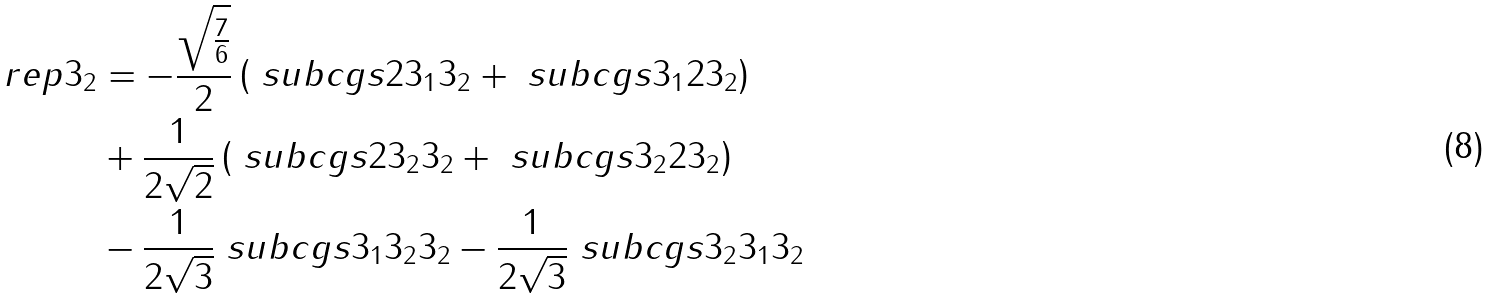Convert formula to latex. <formula><loc_0><loc_0><loc_500><loc_500>\ r e p { 3 } _ { 2 } & = - \frac { \sqrt { \frac { 7 } { 6 } } } { 2 } \left ( \ s u b c g s { 2 } { 3 _ { 1 } } { 3 _ { 2 } } + \ s u b c g s { 3 _ { 1 } } { 2 } { 3 _ { 2 } } \right ) \\ & + \frac { 1 } { 2 \sqrt { 2 } } \left ( \ s u b c g s { 2 } { 3 _ { 2 } } { 3 _ { 2 } } + \ s u b c g s { 3 _ { 2 } } { 2 } { 3 _ { 2 } } \right ) \\ & - \frac { 1 } { 2 \sqrt { 3 } } \ s u b c g s { 3 _ { 1 } } { 3 _ { 2 } } { 3 _ { 2 } } - \frac { 1 } { 2 \sqrt { 3 } } \ s u b c g s { 3 _ { 2 } } { 3 _ { 1 } } { 3 _ { 2 } }</formula> 